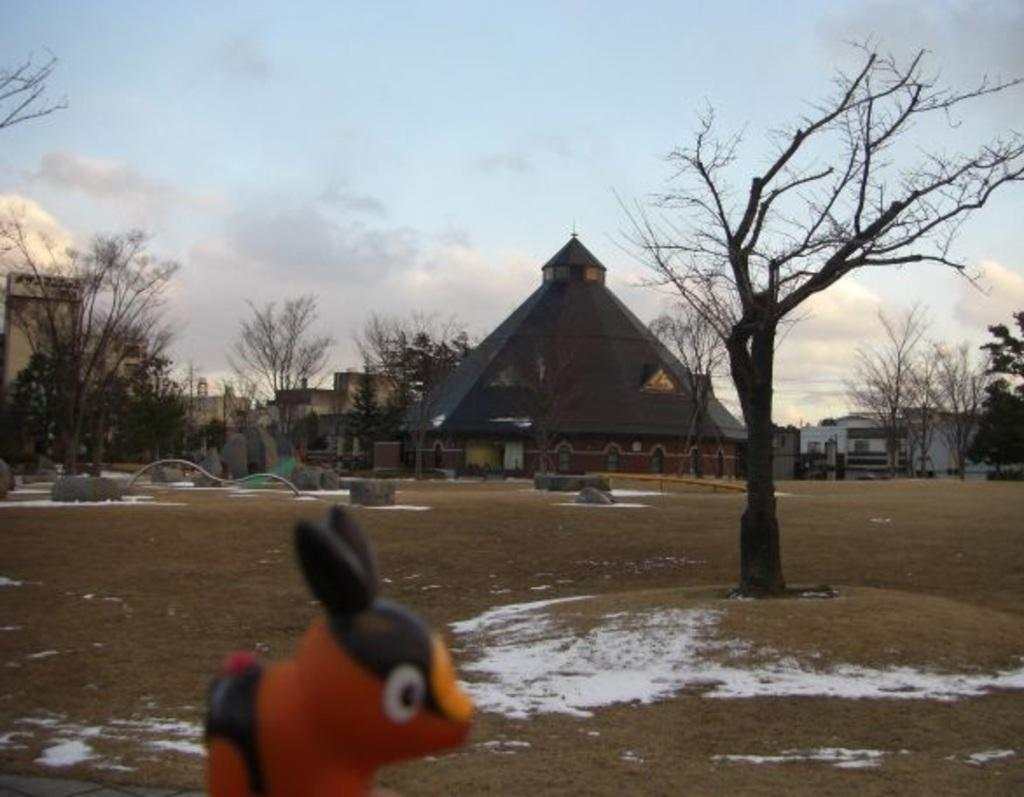What type of structures can be seen in the image? There are buildings in the image. What natural elements are present in the image? There are trees in the image. What type of material is visible in the image? There are stones in the image. What type of object can be seen in the image? There is a toy in the image. What can be seen in the background of the image? The sky is visible in the background of the image. What atmospheric feature is present in the sky? Clouds are present in the sky. Where is the cobweb located in the image? There is no cobweb present in the image. What type of animal is grazing near the buildings in the image? There is no animal, such as a goat, present in the image. 